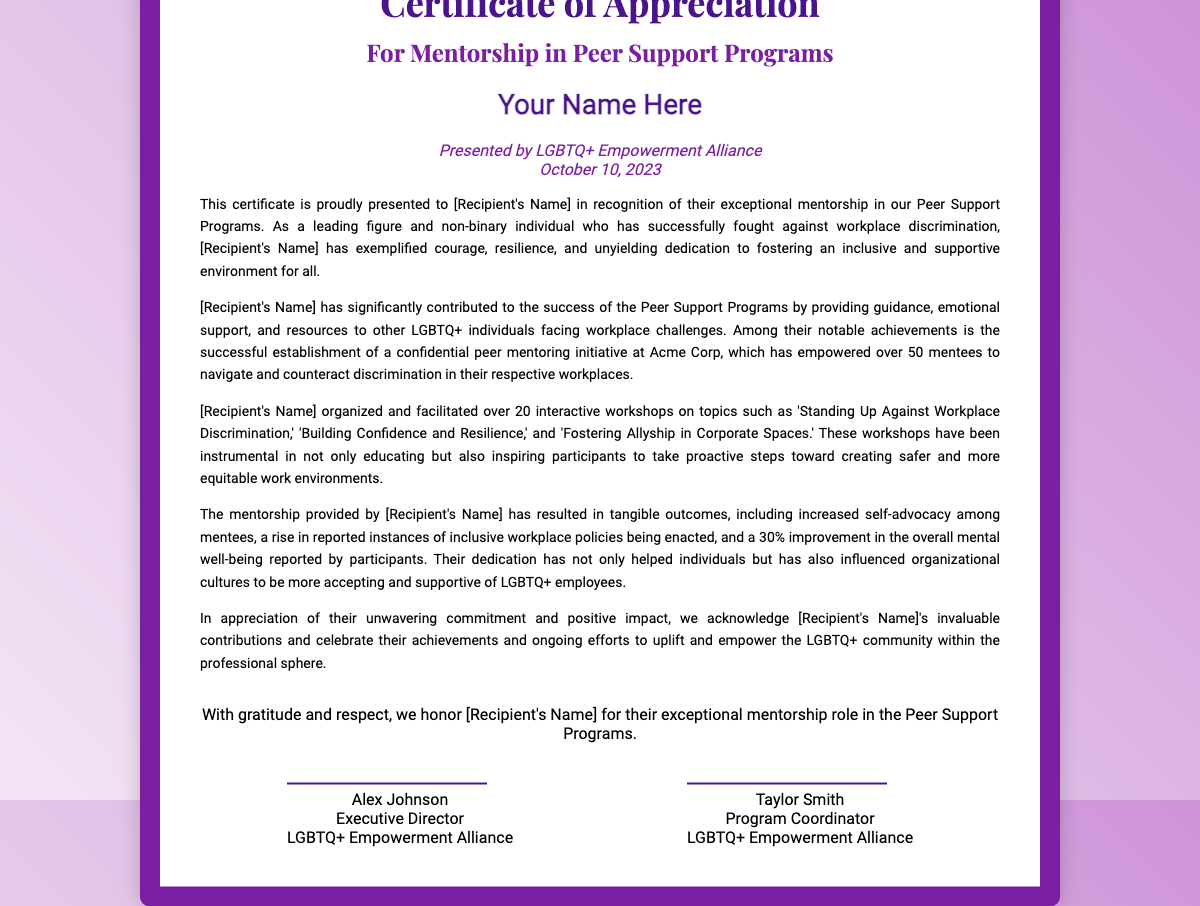What is the title of the certificate? The title is presented prominently at the top of the document.
Answer: Certificate of Appreciation Who presented the certificate? The presenter’s name and organization are mentioned in a designated area of the document.
Answer: LGBTQ+ Empowerment Alliance What is the date on the certificate? The date is indicated near the presenter’s name in the document.
Answer: October 10, 2023 How many interactive workshops did the recipient organize? The document includes specific achievements and their counts.
Answer: 20 What was the name of the peer mentoring initiative established? The initiative established is explicitly mentioned in the document as part of the recipient's contributions.
Answer: confidential peer mentoring initiative What percentage improvement was reported in the overall mental well-being? This detail is specified in the outcomes section of the document.
Answer: 30% Which individual is mentioned as the Executive Director? The signature area contains the name and title of the individuals associated with the certificate.
Answer: Alex Johnson What is the main focus of the workshops organized by the recipient? The document refers to specific topics of the workshops, indicating the overall theme.
Answer: Workplace Discrimination 